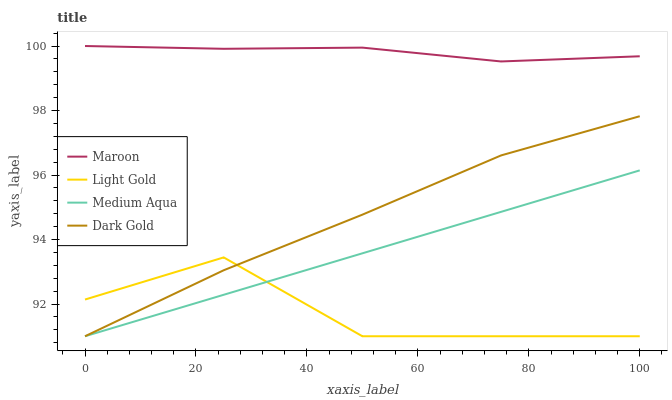Does Maroon have the minimum area under the curve?
Answer yes or no. No. Does Light Gold have the maximum area under the curve?
Answer yes or no. No. Is Maroon the smoothest?
Answer yes or no. No. Is Maroon the roughest?
Answer yes or no. No. Does Maroon have the lowest value?
Answer yes or no. No. Does Light Gold have the highest value?
Answer yes or no. No. Is Medium Aqua less than Maroon?
Answer yes or no. Yes. Is Maroon greater than Dark Gold?
Answer yes or no. Yes. Does Medium Aqua intersect Maroon?
Answer yes or no. No. 